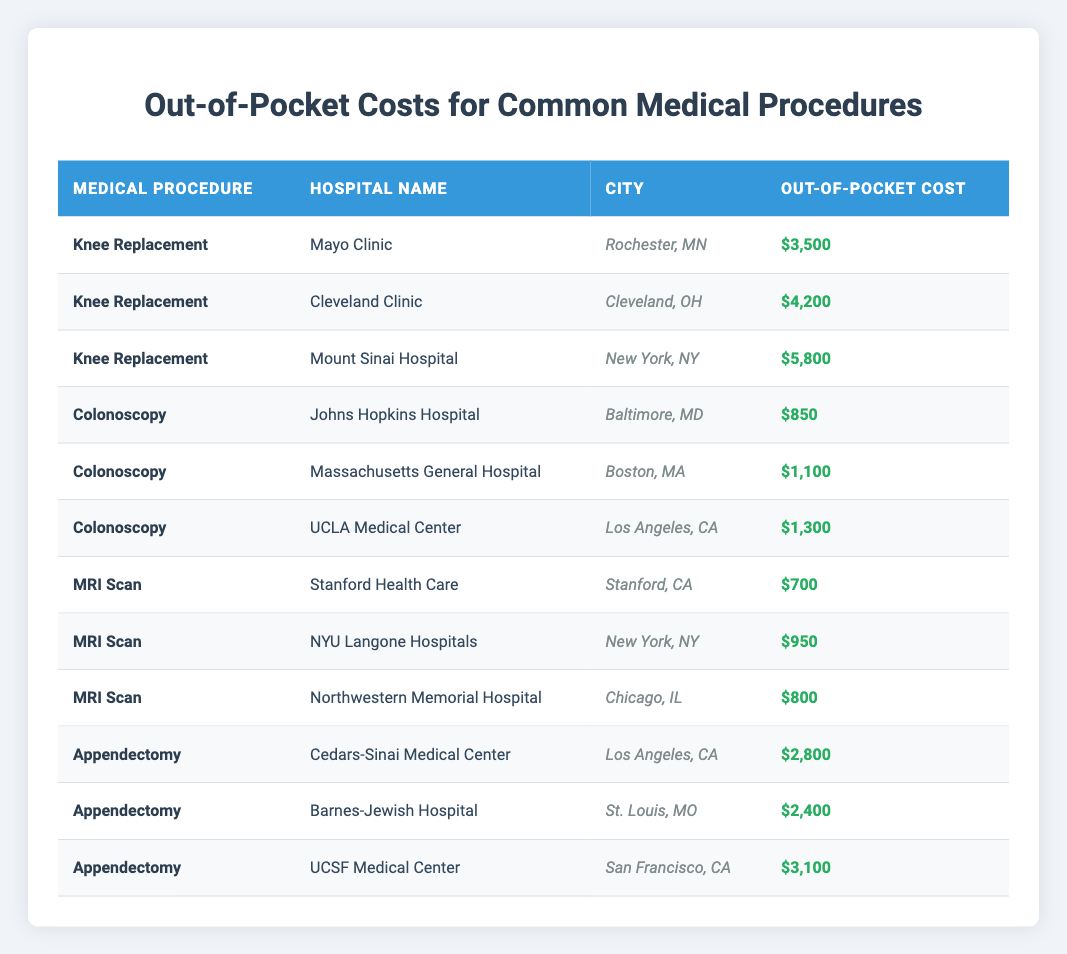What is the out-of-pocket cost for a knee replacement at Mayo Clinic? The table lists the out-of-pocket cost for a knee replacement at Mayo Clinic as $3,500.
Answer: $3,500 Which hospital offers the highest out-of-pocket cost for a colonoscopy? The highest out-of-pocket cost for a colonoscopy is at UCLA Medical Center, which charges $1,300.
Answer: $1,300 How much more does a knee replacement cost at Mount Sinai Hospital compared to Cleveland Clinic? The cost for a knee replacement at Mount Sinai Hospital is $5,800 and at Cleveland Clinic it's $4,200. The difference is $5,800 - $4,200 = $1,600.
Answer: $1,600 Is it true that Stanford Health Care has the lowest out-of-pocket cost for an MRI scan? Yes, the table shows that Stanford Health Care charges $700 for an MRI scan, which is lower compared to the other hospitals listed.
Answer: Yes What is the average out-of-pocket cost for an appendectomy across the three hospitals listed? The costs for appendectomies are $2,800 (Cedars-Sinai), $2,400 (Barnes-Jewish), and $3,100 (UCSF). The total cost is $2,800 + $2,400 + $3,100 = $8,300. The average is $8,300 / 3 = $2,766.67.
Answer: $2,766.67 Where is the hospital with the second highest out-of-pocket cost for a knee replacement located? Mount Sinai Hospital has the second highest cost ($5,800) for a knee replacement and is located in New York, NY.
Answer: New York, NY What is the cost difference between the highest and lowest out-of-pocket costs for MRI scans? The highest cost for an MRI scan is $950 at NYU Langone Hospitals and the lowest is $700 at Stanford Health Care. The difference is $950 - $700 = $250.
Answer: $250 Are all hospitals in the table located in the same state? No, the hospitals are located in various states including Minnesota, Ohio, New York, Maryland, Massachusetts, California, and Missouri.
Answer: No 